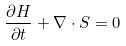<formula> <loc_0><loc_0><loc_500><loc_500>\frac { \partial H } { \partial t } + \nabla \cdot S = 0</formula> 